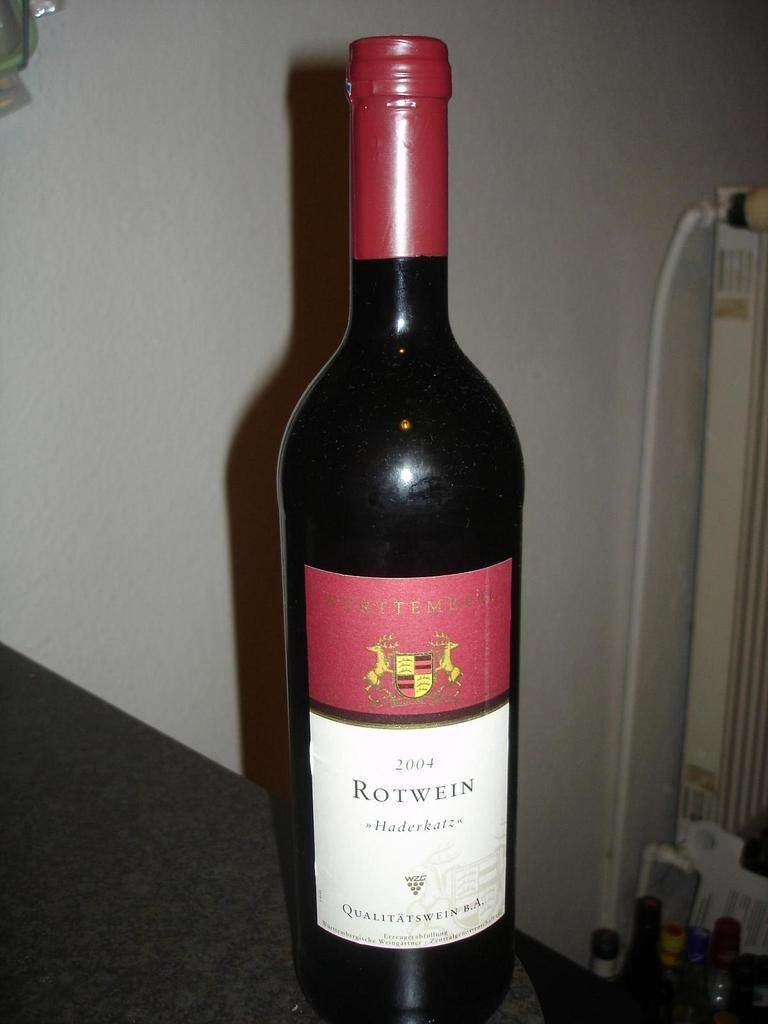Provide a one-sentence caption for the provided image. A Red bottle of wine with the Label ROTWEIN that is unopened and sitting next to a wine glass. 